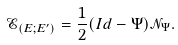Convert formula to latex. <formula><loc_0><loc_0><loc_500><loc_500>\mathcal { E } _ { ( E ; E ^ { \prime } ) } = \frac { 1 } { 2 } ( I d - \Psi ) \mathcal { N } _ { \Psi } .</formula> 